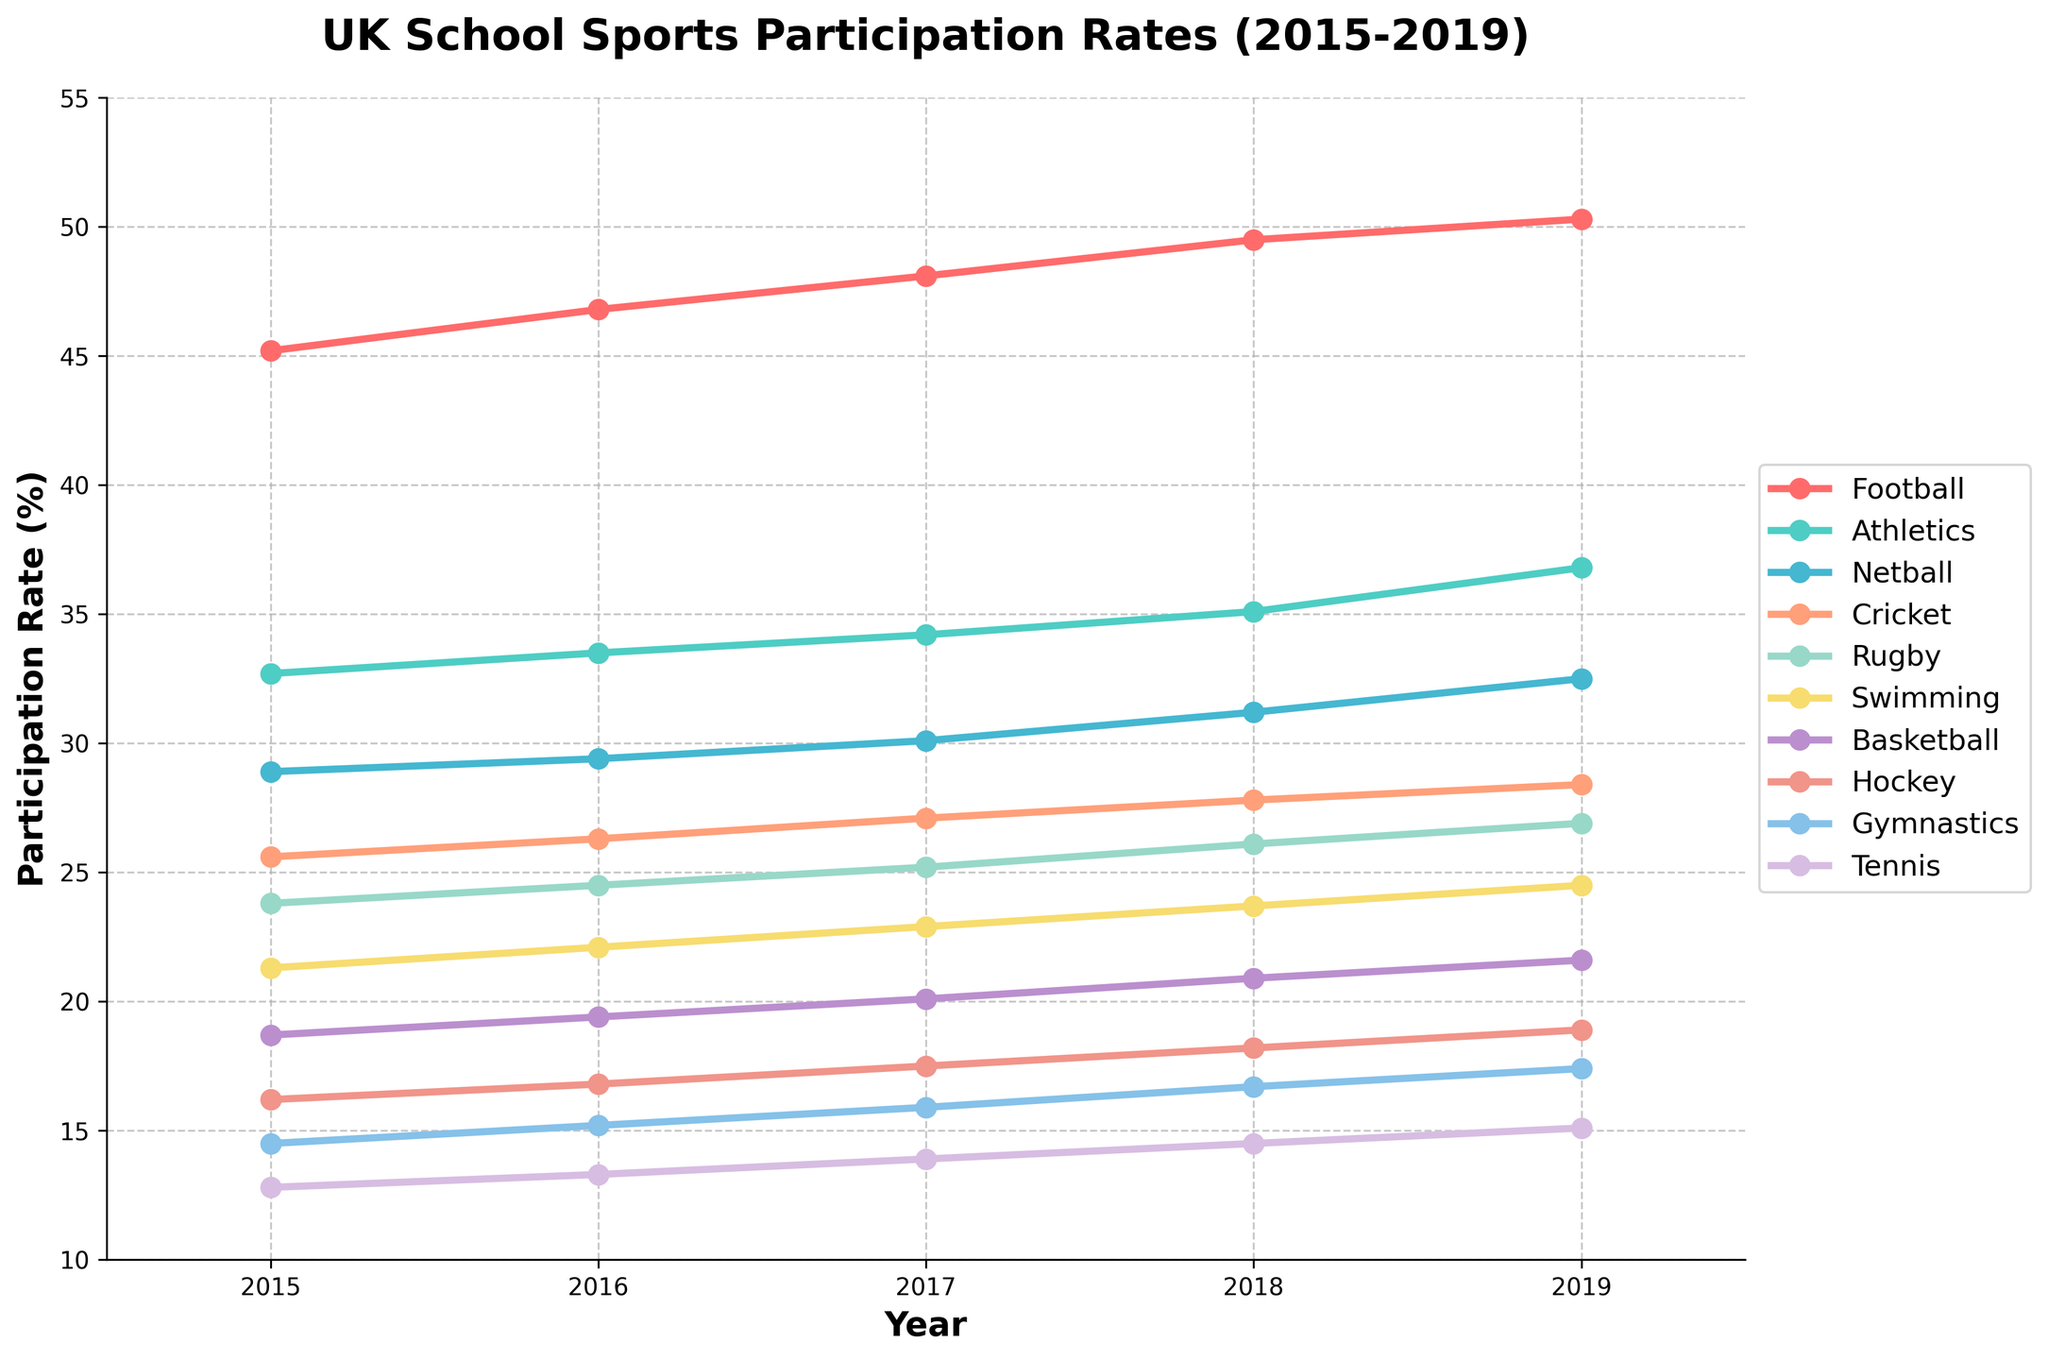What's the participation rate in Football in 2019? Locate the Football line in the graph and find the point corresponding to 2019 on the x-axis.
Answer: 50.3% Which sport had the lowest participation rate in 2015, and what was the rate? Examine all the sports' participation rates in 2015 and identify the lowest value.
Answer: Tennis, 12.8% What is the difference in participation rates between Football and Athletics in 2019? Find the participation rates of both Football and Athletics in 2019, then subtract the Athletics rate from the Football rate.
Answer: 13.5% Which sport showed the greatest increase in participation from 2015 to 2019? Calculate the increase for each sport by subtracting the 2015 participation rate from the 2019 participation rate. Identify the sport with the highest increase.
Answer: Athletics How many sports had a participation rate greater than 30% in 2019? Identify the sports with participation rates above 30% in 2019 and count them.
Answer: 3 Compare the participation trends of Netball and Basketball. Which one had a higher growth rate from 2015 to 2019? Calculate the growth rate for both Netball and Basketball by finding the difference between their 2019 and 2015 rates, then compare these differences.
Answer: Netball What's the average participation rate for Gymnastics from 2015 to 2019? Add the annual participation rates for Gymnastics from 2015 to 2019, then divide by the number of years (5).
Answer: 15.94% Which sport had a participation rate of around 22.9% in 2017? Locate the line for 2017 and find the sport close to the participation rate of 22.9%.
Answer: Swimming Describe the trend for participation in Rugby from 2015 to 2019. Observe the line graph for Rugby and describe its progression in the given years. Identify whether it increases, decreases, or remains consistent.
Answer: Increasing Which two sports had participation rates that were most similar in 2018? Compare the participation rates for all sports in 2018 and identify the two with the closest values.
Answer: Netball and Cricket 